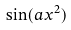<formula> <loc_0><loc_0><loc_500><loc_500>\sin ( a x ^ { 2 } )</formula> 